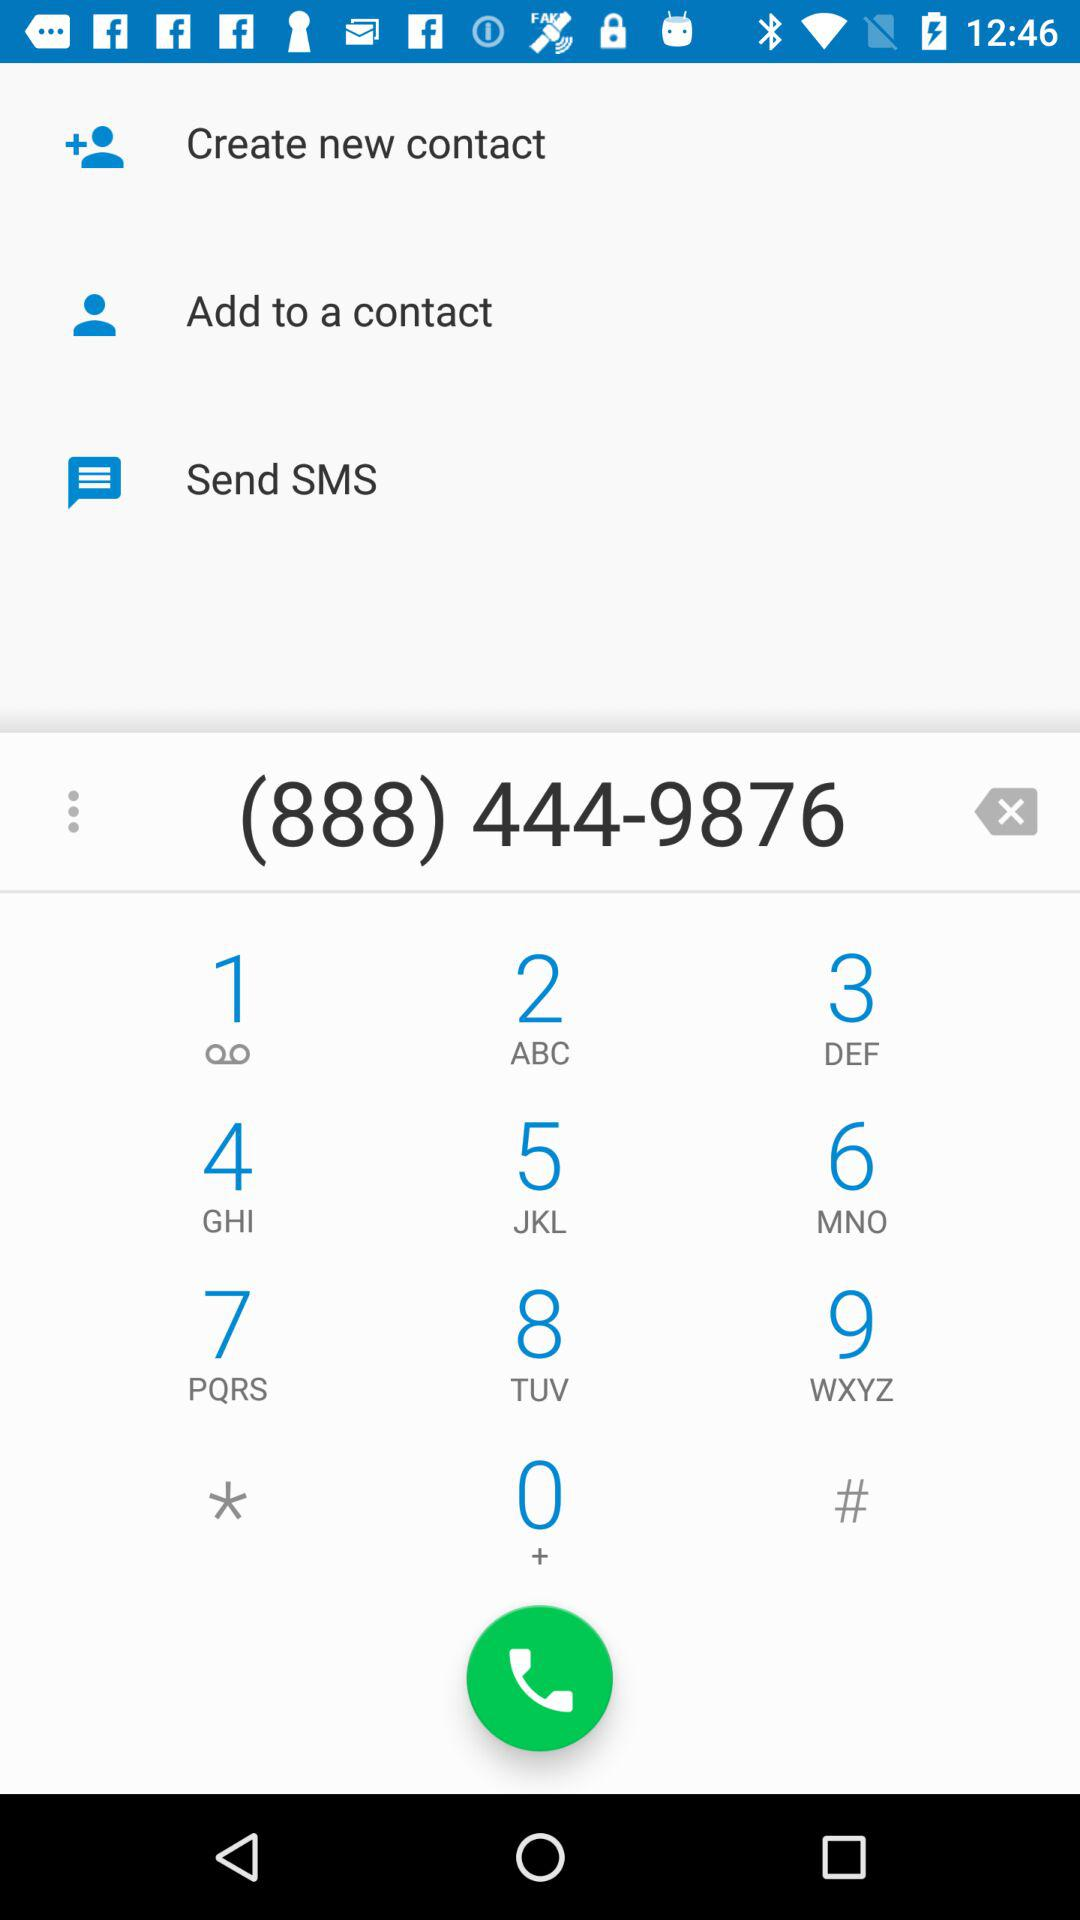What are the options that I can use for the contact number? The options that you can use for the contact number are "Create new contact", "Add to a contact", "Send SMS" and "Call". 